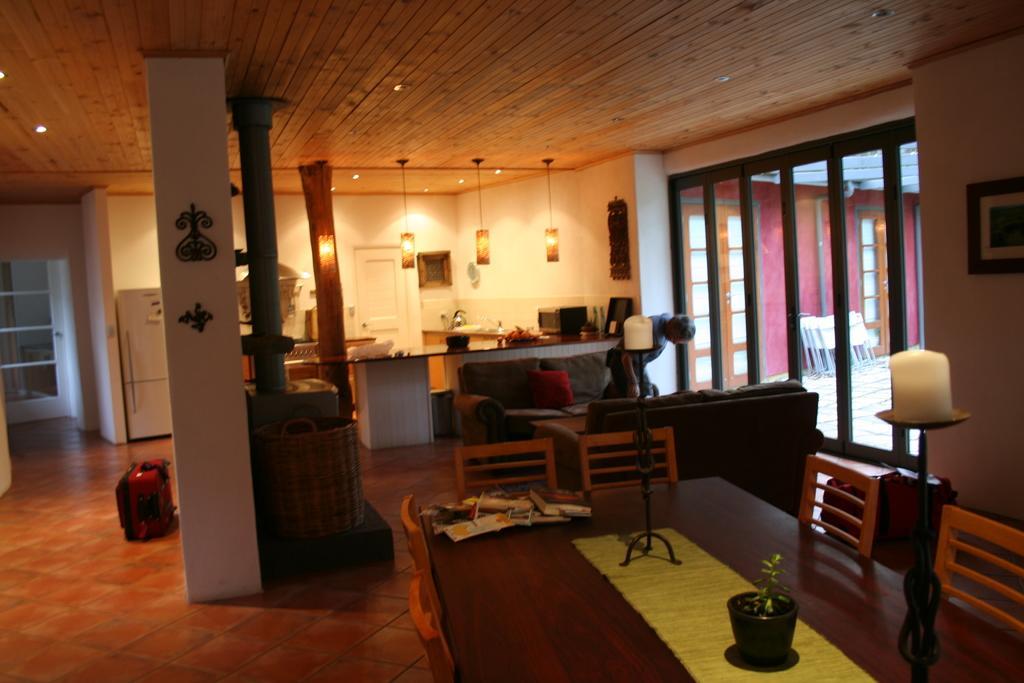Could you give a brief overview of what you see in this image? This looks like a living room. I can see a man standing. This is a couch. This is a table with a small flower pot ,some books and a yellow dining mat on it. These are the empty chairs. I can see a lamp hanging through the rooftop. This looks like a refrigerator. Here is a photo frame attached to the wall. And this looks like a kitchen area. And here I can see a luggage bag. 